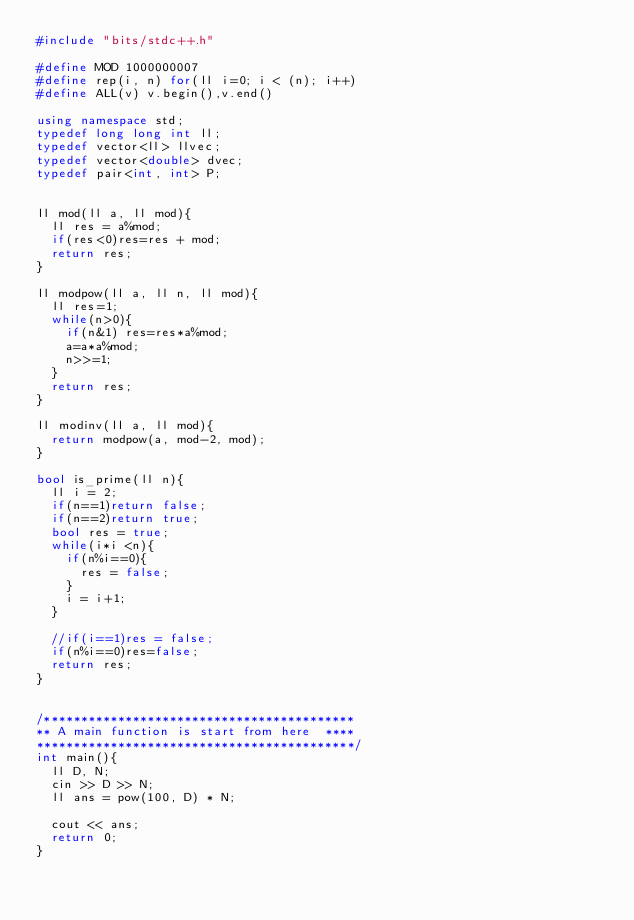Convert code to text. <code><loc_0><loc_0><loc_500><loc_500><_C++_>#include "bits/stdc++.h"

#define MOD 1000000007
#define rep(i, n) for(ll i=0; i < (n); i++)
#define ALL(v) v.begin(),v.end()

using namespace std;
typedef long long int ll;
typedef vector<ll> llvec;
typedef vector<double> dvec;
typedef pair<int, int> P;


ll mod(ll a, ll mod){
  ll res = a%mod;
  if(res<0)res=res + mod;
  return res;
}

ll modpow(ll a, ll n, ll mod){
  ll res=1;
  while(n>0){
    if(n&1) res=res*a%mod;
    a=a*a%mod;
    n>>=1;
  }
  return res;
}

ll modinv(ll a, ll mod){
  return modpow(a, mod-2, mod);
}

bool is_prime(ll n){
  ll i = 2;
  if(n==1)return false;
  if(n==2)return true;
  bool res = true;
  while(i*i <n){
    if(n%i==0){
      res = false;
    }
    i = i+1;
  }

  //if(i==1)res = false;
  if(n%i==0)res=false;
  return res;
}


/******************************************
** A main function is start from here  ****
*******************************************/
int main(){
  ll D, N;
  cin >> D >> N;
  ll ans = pow(100, D) * N;
  
  cout << ans;
  return 0;
}
</code> 